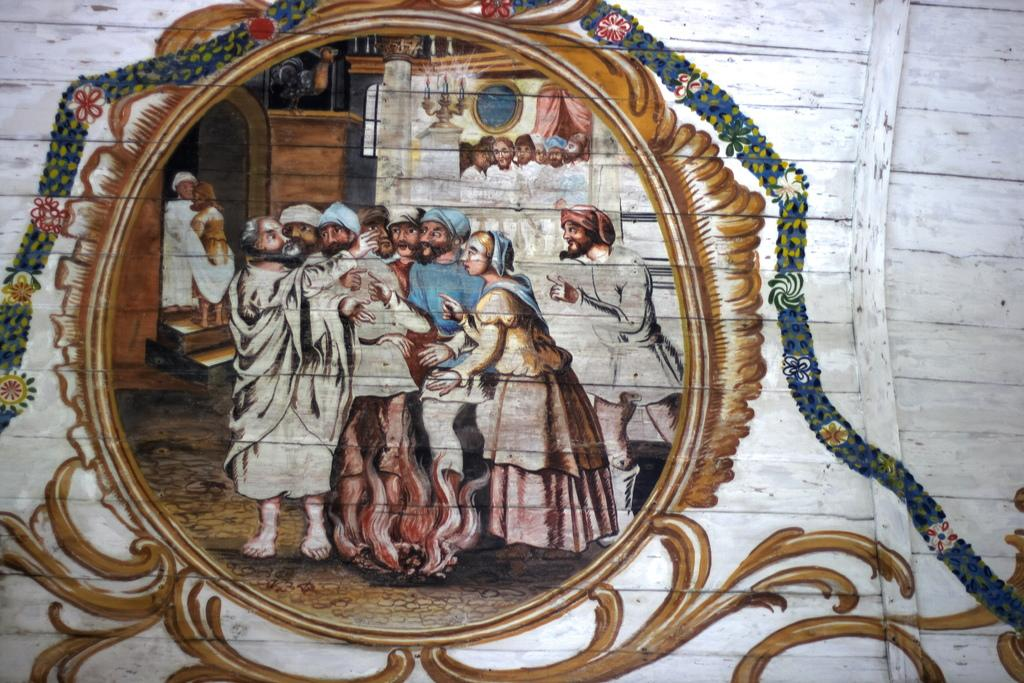What is the main subject of the painting in the image? The painting depicts flowers and people. What objects can be seen in the painting? There are candles and a candle stand in the painting. How is the painting displayed in the image? The painting has a frame attached to the wall, and it is on a wooden object. What type of lead is used to create the painting in the image? There is no information about the materials used to create the painting in the image, so we cannot determine the type of lead used. What flavor of juice is being served in the painting? There is no mention of juice in the painting or the image, so we cannot determine the flavor being served. 